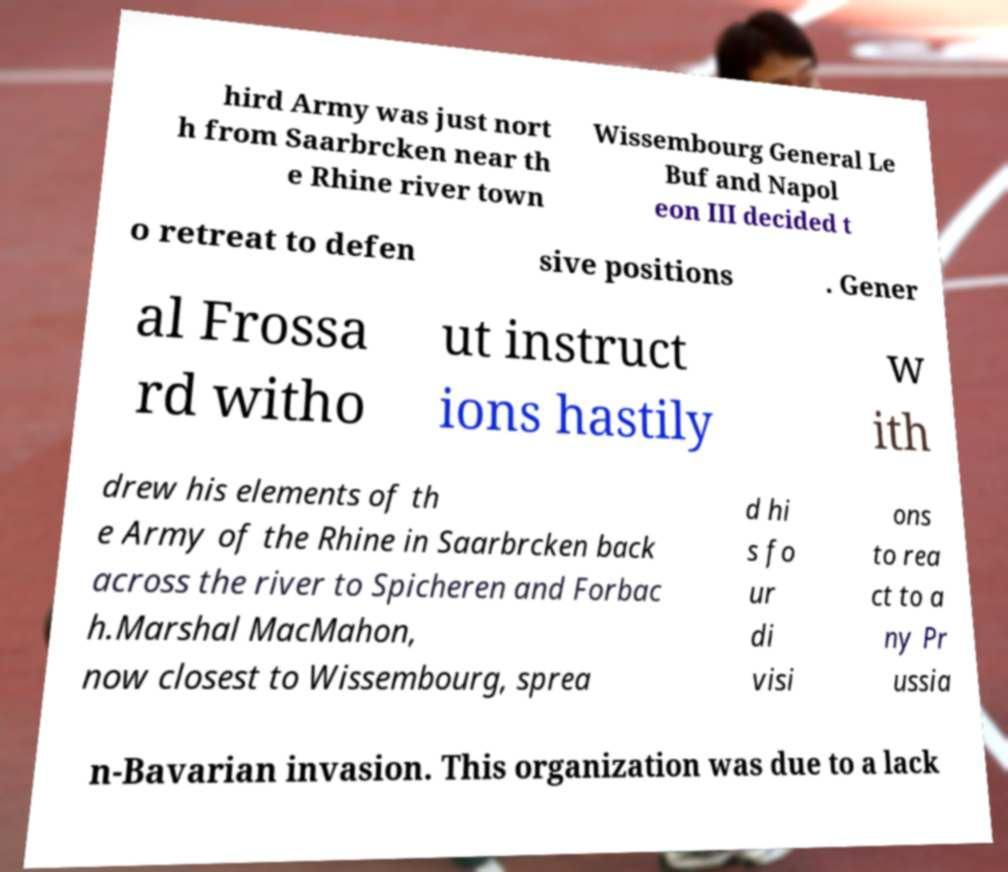Please identify and transcribe the text found in this image. hird Army was just nort h from Saarbrcken near th e Rhine river town Wissembourg General Le Buf and Napol eon III decided t o retreat to defen sive positions . Gener al Frossa rd witho ut instruct ions hastily w ith drew his elements of th e Army of the Rhine in Saarbrcken back across the river to Spicheren and Forbac h.Marshal MacMahon, now closest to Wissembourg, sprea d hi s fo ur di visi ons to rea ct to a ny Pr ussia n-Bavarian invasion. This organization was due to a lack 